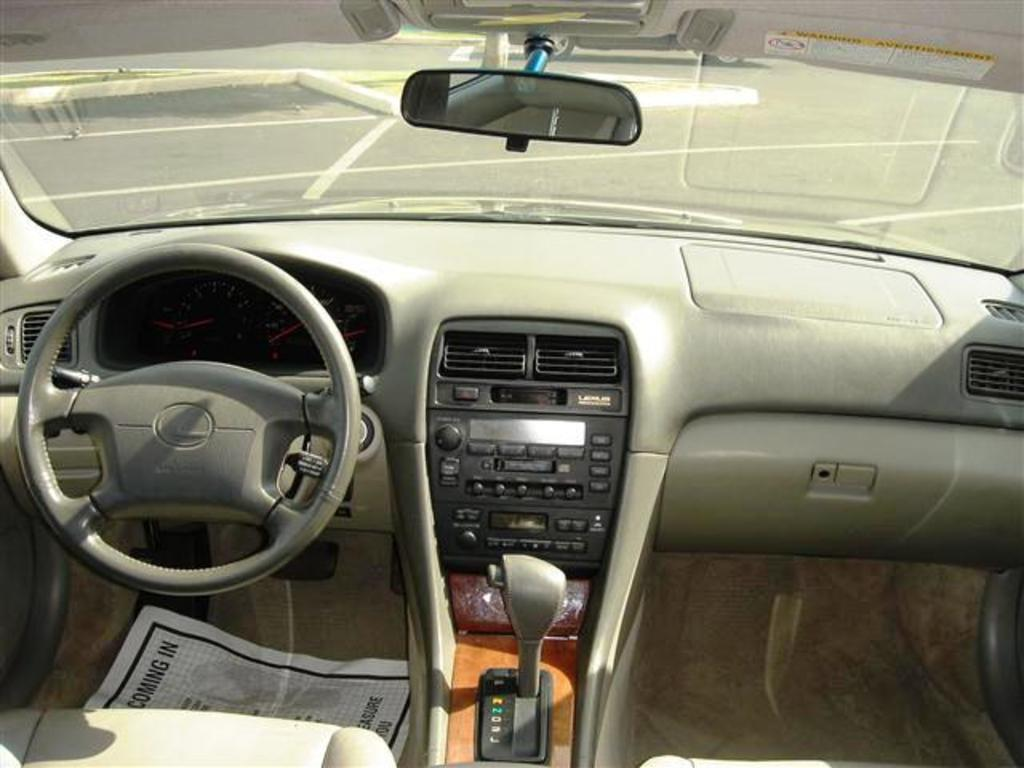Where was the image taken? The image was taken inside a car. What is the main control device in the car? There is a steering wheel in the image. What instrument is used to measure the speed of the car? There are speedometers in the image. How does the driver change the gears in the car? There is a gear rod in the image. What other equipment related to the car can be seen in the image? There are other equipment related to the car in the image. How many partners are visible in the image? There are no partners visible in the image, as it is taken inside a car and features car-related equipment. 